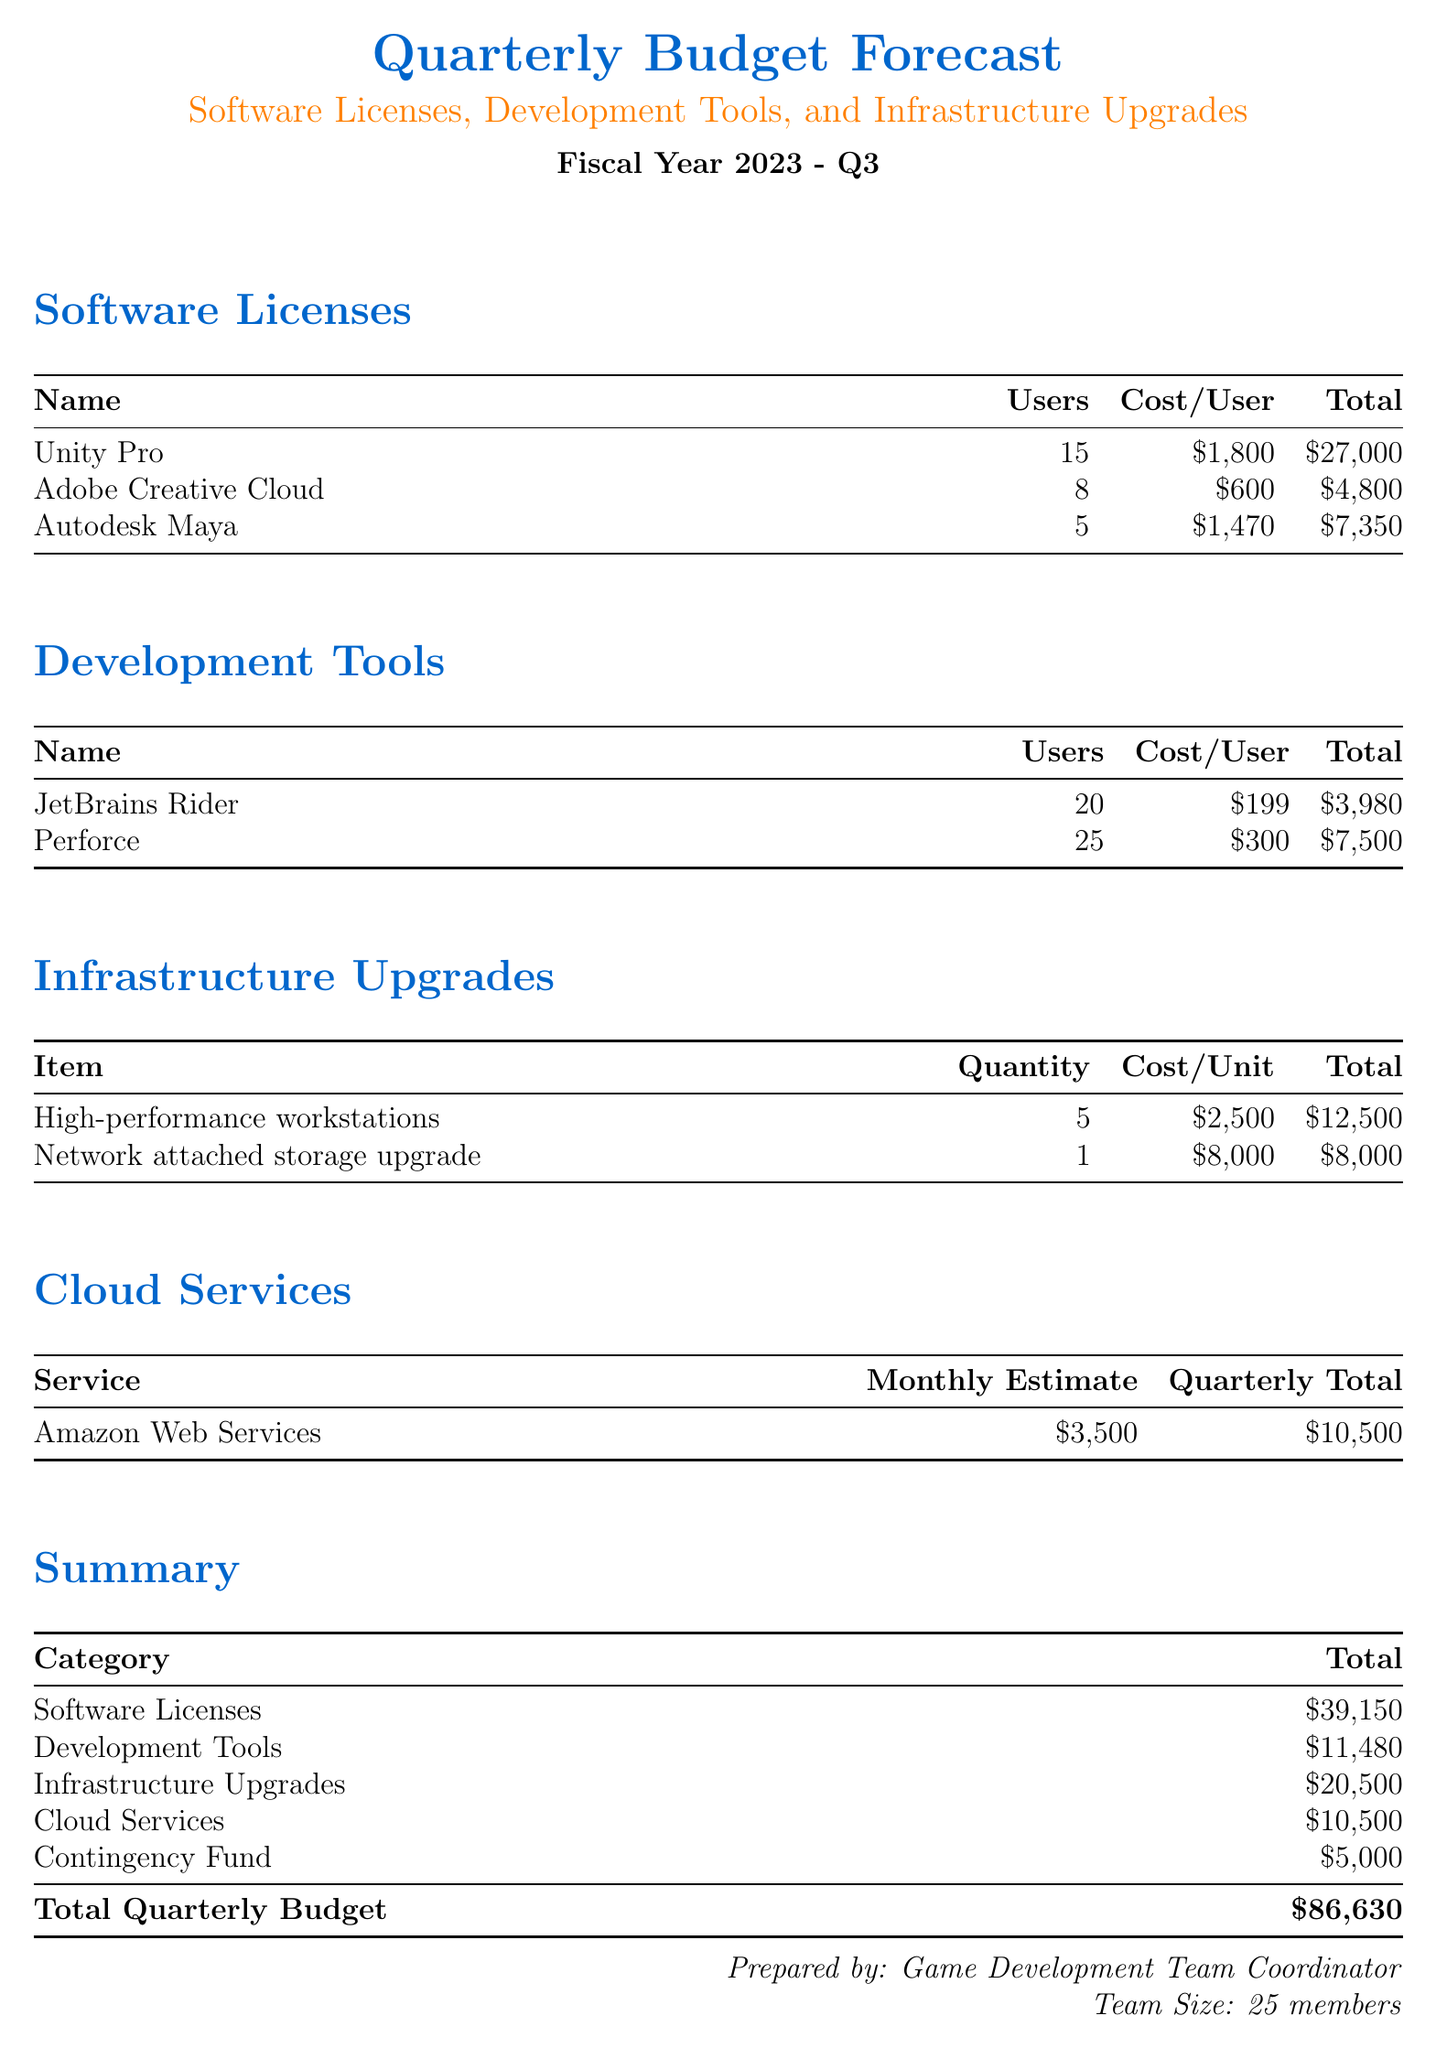What is the total cost for software licenses? The total cost for software licenses is listed at the bottom of the Software Licenses section, which sums up to $39,150.
Answer: $39,150 How many users have access to Adobe Creative Cloud? The number of users for Adobe Creative Cloud is specified in the Software Licenses table as 8 users.
Answer: 8 What is the total cost for development tools? The total cost for development tools is presented at the end of the Development Tools section, and it is $11,480.
Answer: $11,480 How many high-performance workstations are being purchased? The quantity of high-performance workstations is specified in the Infrastructure Upgrades section, shown as 5 units.
Answer: 5 What is the quarterly total for Amazon Web Services? The quarterly total for Amazon Web Services is shown in the Cloud Services section as $10,500.
Answer: $10,500 How much is allocated for the contingency fund? The contingency fund is listed in the Summary section, where the amount is stated to be $5,000.
Answer: $5,000 What is the cost per user for Unity Pro? The cost per user for Unity Pro is specified in the Software Licenses section, which is $1,800.
Answer: $1,800 What is the total budget for the quarter? The total quarterly budget is calculated and displayed at the bottom of the Summary section as $86,630.
Answer: $86,630 How many users are using Perforce? The number of users for Perforce is outlined in the Development Tools section, which states there are 25 users.
Answer: 25 